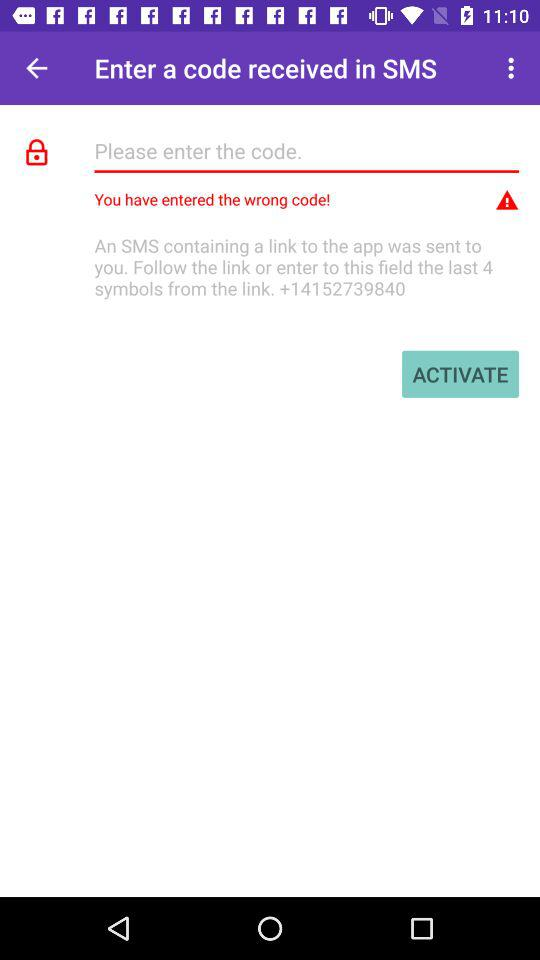How many digits long is the code?
Answer the question using a single word or phrase. 4 